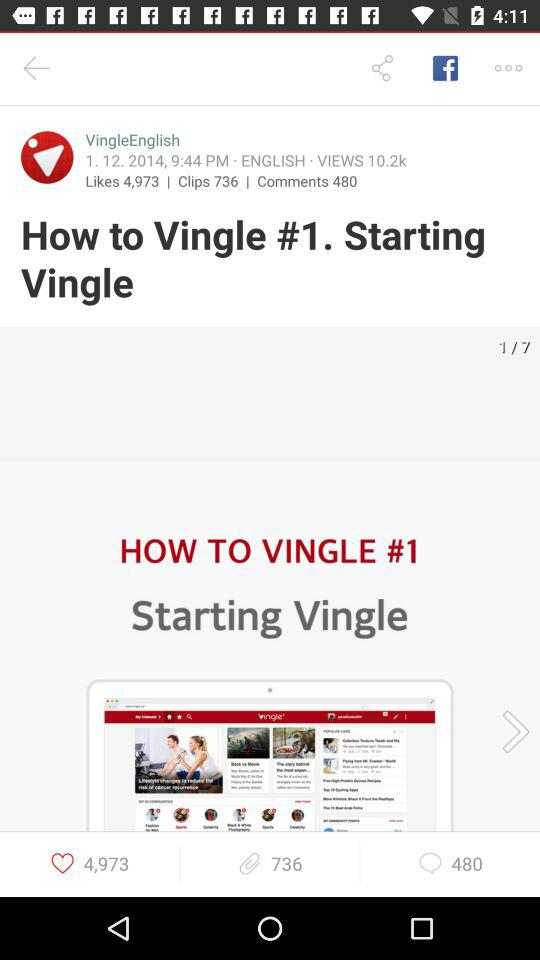Which image number are we currently on? You are currently on the first image. 